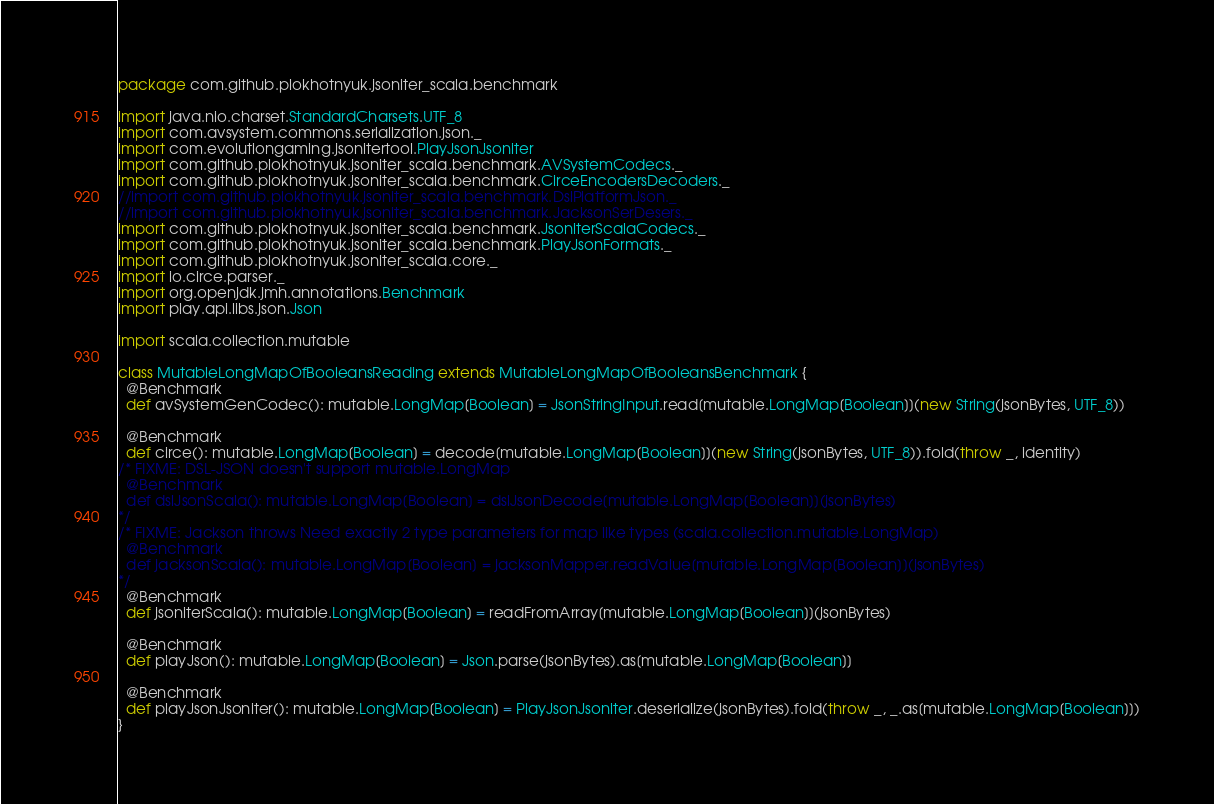<code> <loc_0><loc_0><loc_500><loc_500><_Scala_>package com.github.plokhotnyuk.jsoniter_scala.benchmark

import java.nio.charset.StandardCharsets.UTF_8
import com.avsystem.commons.serialization.json._
import com.evolutiongaming.jsonitertool.PlayJsonJsoniter
import com.github.plokhotnyuk.jsoniter_scala.benchmark.AVSystemCodecs._
import com.github.plokhotnyuk.jsoniter_scala.benchmark.CirceEncodersDecoders._
//import com.github.plokhotnyuk.jsoniter_scala.benchmark.DslPlatformJson._
//import com.github.plokhotnyuk.jsoniter_scala.benchmark.JacksonSerDesers._
import com.github.plokhotnyuk.jsoniter_scala.benchmark.JsoniterScalaCodecs._
import com.github.plokhotnyuk.jsoniter_scala.benchmark.PlayJsonFormats._
import com.github.plokhotnyuk.jsoniter_scala.core._
import io.circe.parser._
import org.openjdk.jmh.annotations.Benchmark
import play.api.libs.json.Json

import scala.collection.mutable

class MutableLongMapOfBooleansReading extends MutableLongMapOfBooleansBenchmark {
  @Benchmark
  def avSystemGenCodec(): mutable.LongMap[Boolean] = JsonStringInput.read[mutable.LongMap[Boolean]](new String(jsonBytes, UTF_8))

  @Benchmark
  def circe(): mutable.LongMap[Boolean] = decode[mutable.LongMap[Boolean]](new String(jsonBytes, UTF_8)).fold(throw _, identity)
/* FIXME: DSL-JSON doesn't support mutable.LongMap
  @Benchmark
  def dslJsonScala(): mutable.LongMap[Boolean] = dslJsonDecode[mutable.LongMap[Boolean]](jsonBytes)
*/
/* FIXME: Jackson throws Need exactly 2 type parameters for map like types (scala.collection.mutable.LongMap)
  @Benchmark
  def jacksonScala(): mutable.LongMap[Boolean] = jacksonMapper.readValue[mutable.LongMap[Boolean]](jsonBytes)
*/
  @Benchmark
  def jsoniterScala(): mutable.LongMap[Boolean] = readFromArray[mutable.LongMap[Boolean]](jsonBytes)

  @Benchmark
  def playJson(): mutable.LongMap[Boolean] = Json.parse(jsonBytes).as[mutable.LongMap[Boolean]]

  @Benchmark
  def playJsonJsoniter(): mutable.LongMap[Boolean] = PlayJsonJsoniter.deserialize(jsonBytes).fold(throw _, _.as[mutable.LongMap[Boolean]])
}</code> 